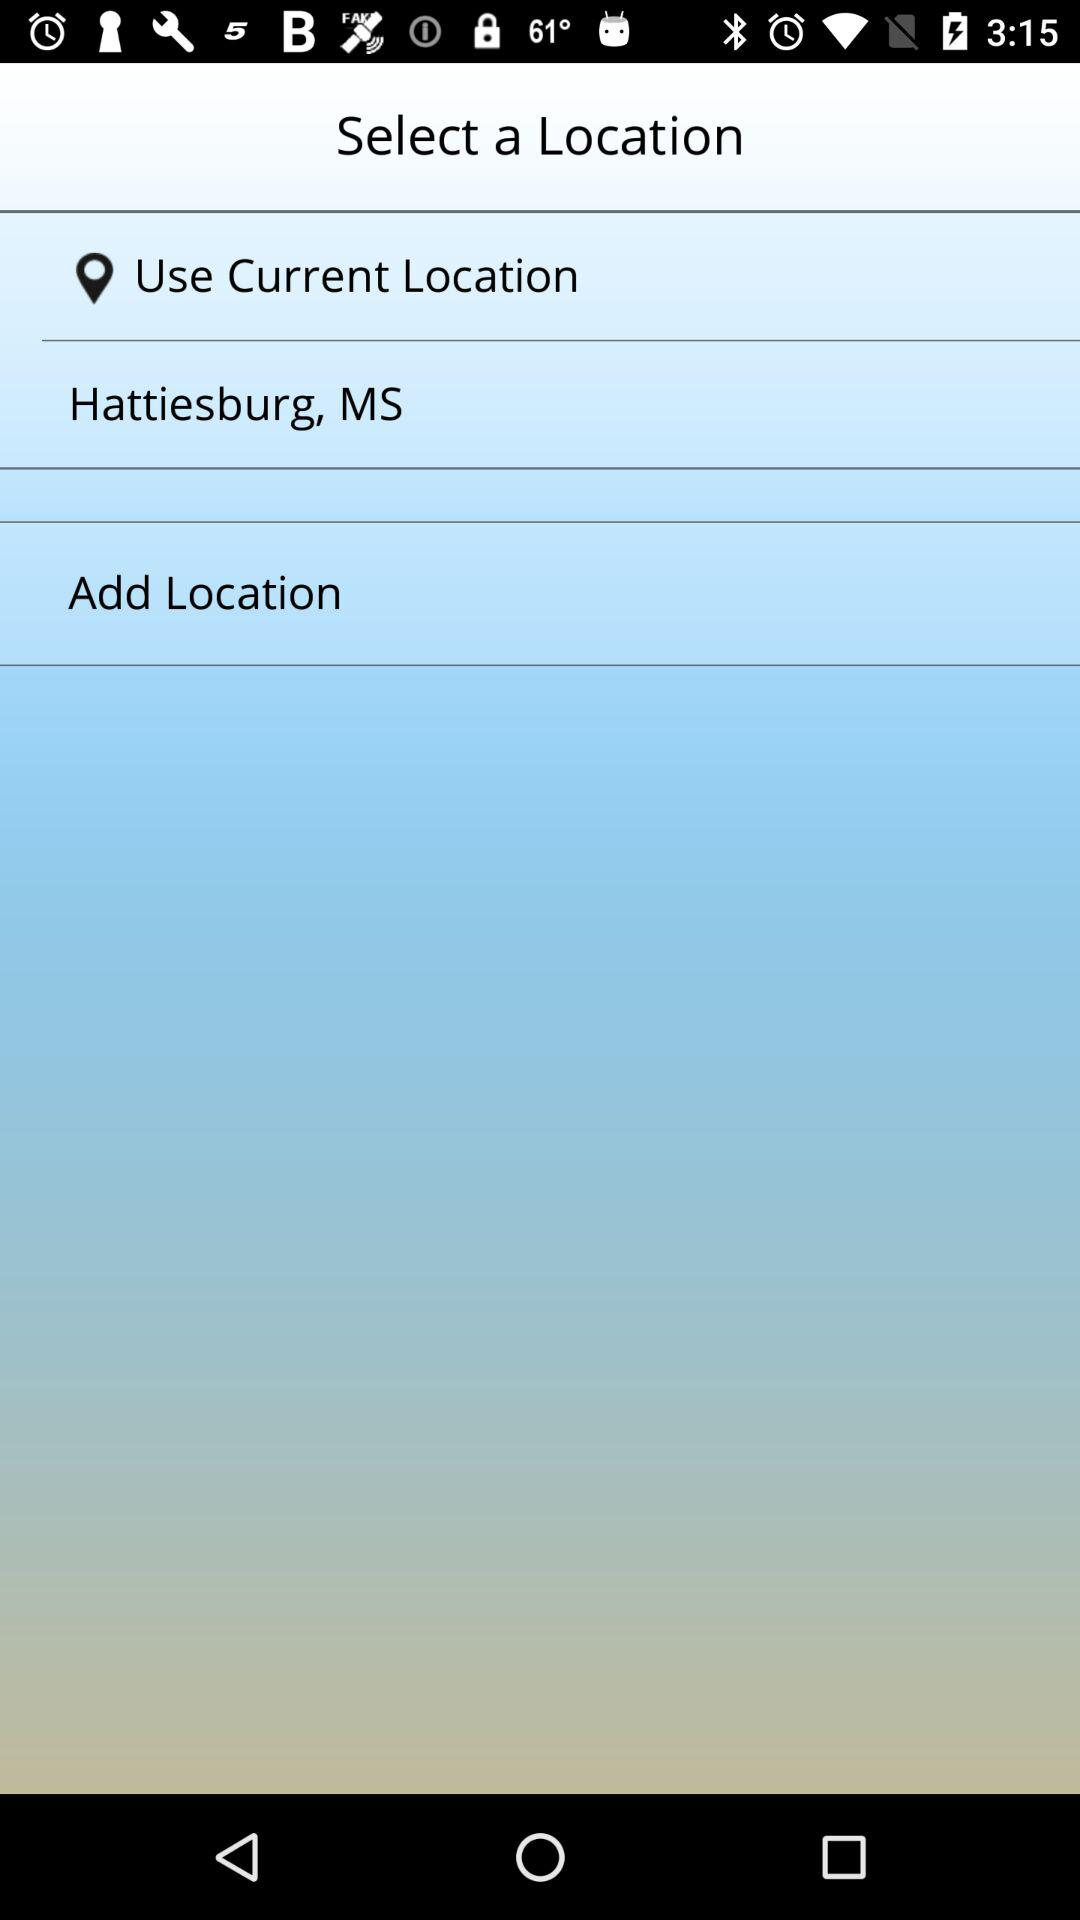What is the mentioned location? The mentioned location is Hattiesburg, MS. 